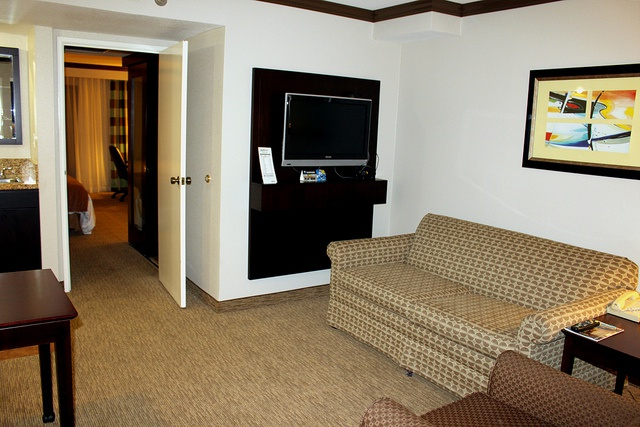Describe the objects in this image and their specific colors. I can see couch in darkgray, tan, and gray tones, couch in darkgray, maroon, black, and gray tones, chair in darkgray, maroon, gray, and black tones, dining table in darkgray, black, maroon, and gray tones, and tv in darkgray, black, and gray tones in this image. 